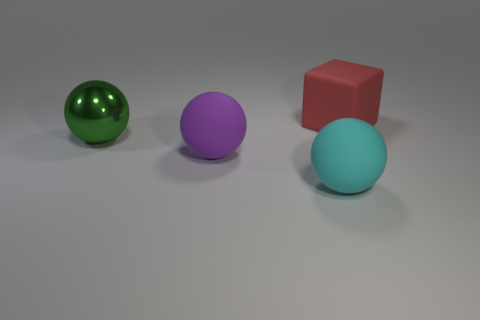What is the material of the big object on the right side of the big cyan matte ball?
Offer a very short reply. Rubber. What is the size of the ball right of the rubber thing on the left side of the large ball to the right of the purple ball?
Make the answer very short. Large. There is a red matte thing; is its size the same as the matte sphere that is behind the big cyan ball?
Ensure brevity in your answer.  Yes. What is the color of the big object that is behind the large green metal object?
Give a very brief answer. Red. There is a matte thing in front of the big purple ball; what is its shape?
Give a very brief answer. Sphere. What number of blue objects are either big shiny objects or matte blocks?
Provide a short and direct response. 0. Is the material of the big green ball the same as the cyan ball?
Give a very brief answer. No. How many big things are behind the green shiny thing?
Provide a short and direct response. 1. There is a big thing that is both to the left of the large cyan sphere and in front of the green metallic ball; what is it made of?
Keep it short and to the point. Rubber. What number of cylinders are large green metal objects or small cyan matte things?
Provide a succinct answer. 0. 